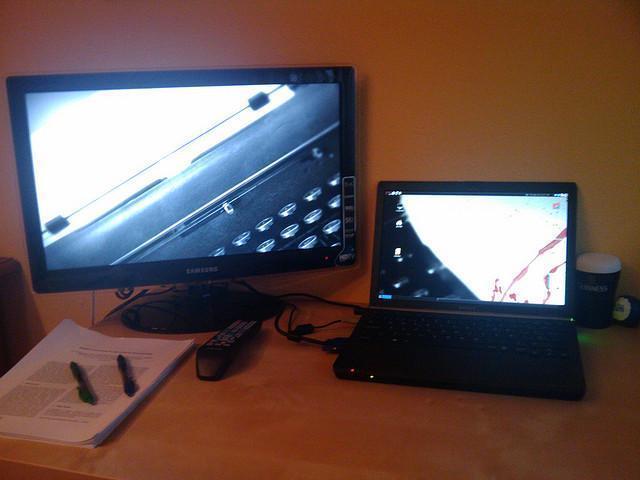How many monitors are there?
Give a very brief answer. 2. 